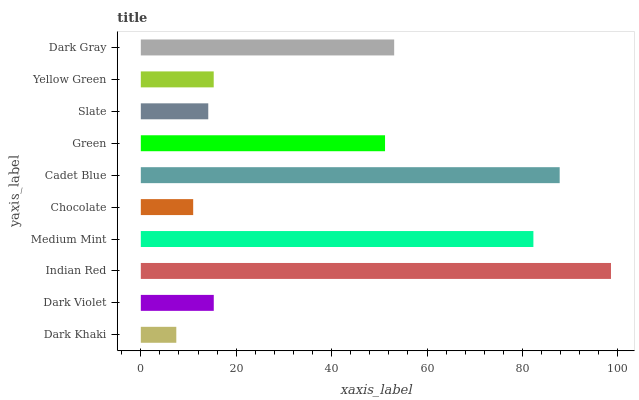Is Dark Khaki the minimum?
Answer yes or no. Yes. Is Indian Red the maximum?
Answer yes or no. Yes. Is Dark Violet the minimum?
Answer yes or no. No. Is Dark Violet the maximum?
Answer yes or no. No. Is Dark Violet greater than Dark Khaki?
Answer yes or no. Yes. Is Dark Khaki less than Dark Violet?
Answer yes or no. Yes. Is Dark Khaki greater than Dark Violet?
Answer yes or no. No. Is Dark Violet less than Dark Khaki?
Answer yes or no. No. Is Green the high median?
Answer yes or no. Yes. Is Dark Violet the low median?
Answer yes or no. Yes. Is Yellow Green the high median?
Answer yes or no. No. Is Chocolate the low median?
Answer yes or no. No. 